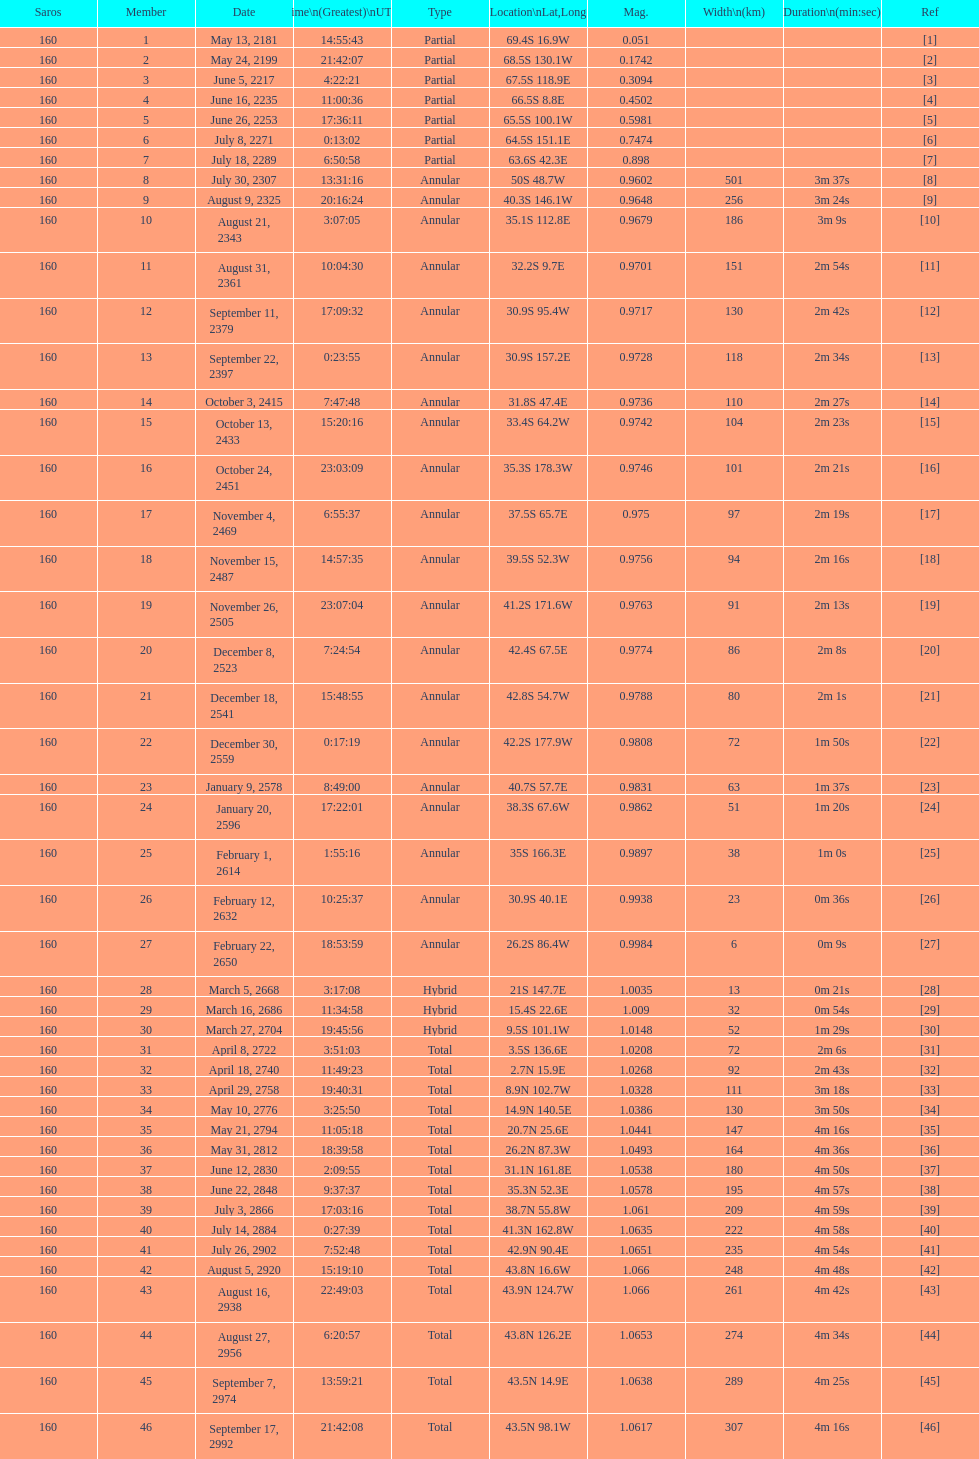What is the contrast in magnitude between the may 13, 2181 solar saros and the may 24, 2199 solar saros? 0.1232. 